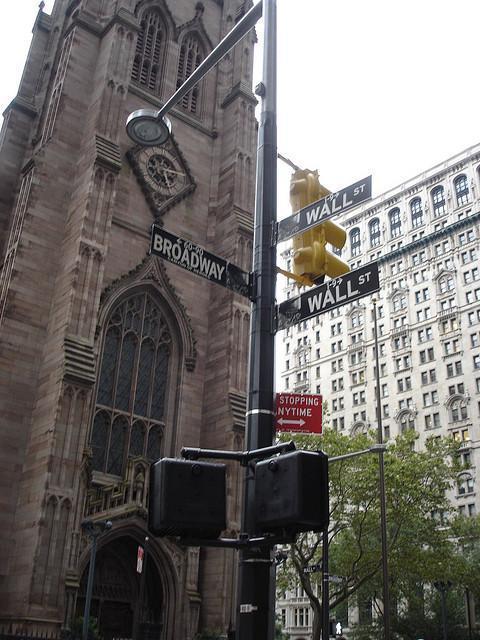How many streets are advertised?
Give a very brief answer. 2. How many traffic lights can you see?
Give a very brief answer. 3. How many slices is the sandwich cut up?
Give a very brief answer. 0. 